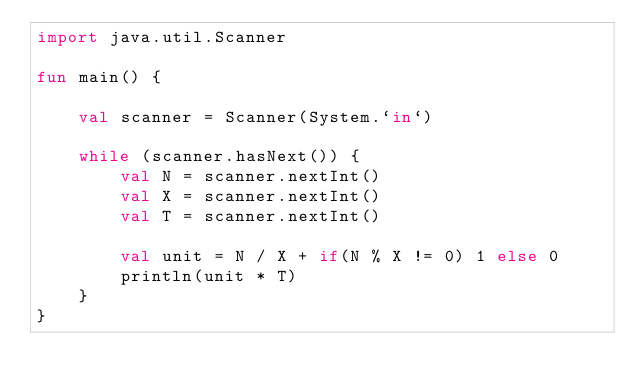<code> <loc_0><loc_0><loc_500><loc_500><_Kotlin_>import java.util.Scanner

fun main() {

    val scanner = Scanner(System.`in`)

    while (scanner.hasNext()) {
        val N = scanner.nextInt()
        val X = scanner.nextInt()
        val T = scanner.nextInt()

        val unit = N / X + if(N % X != 0) 1 else 0
        println(unit * T)
    }
}</code> 